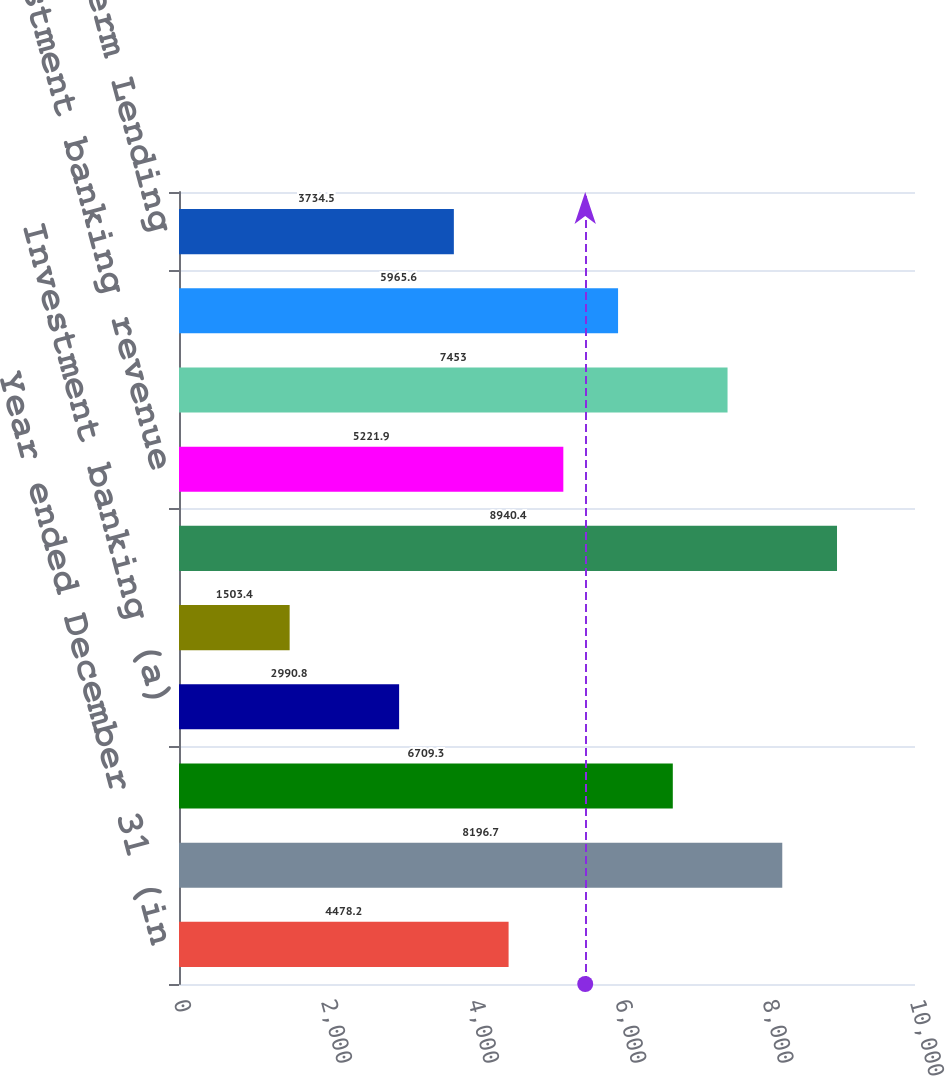Convert chart. <chart><loc_0><loc_0><loc_500><loc_500><bar_chart><fcel>Year ended December 31 (in<fcel>Lending<fcel>Treasury services<fcel>Investment banking (a)<fcel>Other (b)<fcel>Total Commercial Banking net<fcel>Investment banking revenue<fcel>Middle Market Banking (d)<fcel>Corporate Client Banking (d)<fcel>Commercial Term Lending<nl><fcel>4478.2<fcel>8196.7<fcel>6709.3<fcel>2990.8<fcel>1503.4<fcel>8940.4<fcel>5221.9<fcel>7453<fcel>5965.6<fcel>3734.5<nl></chart> 